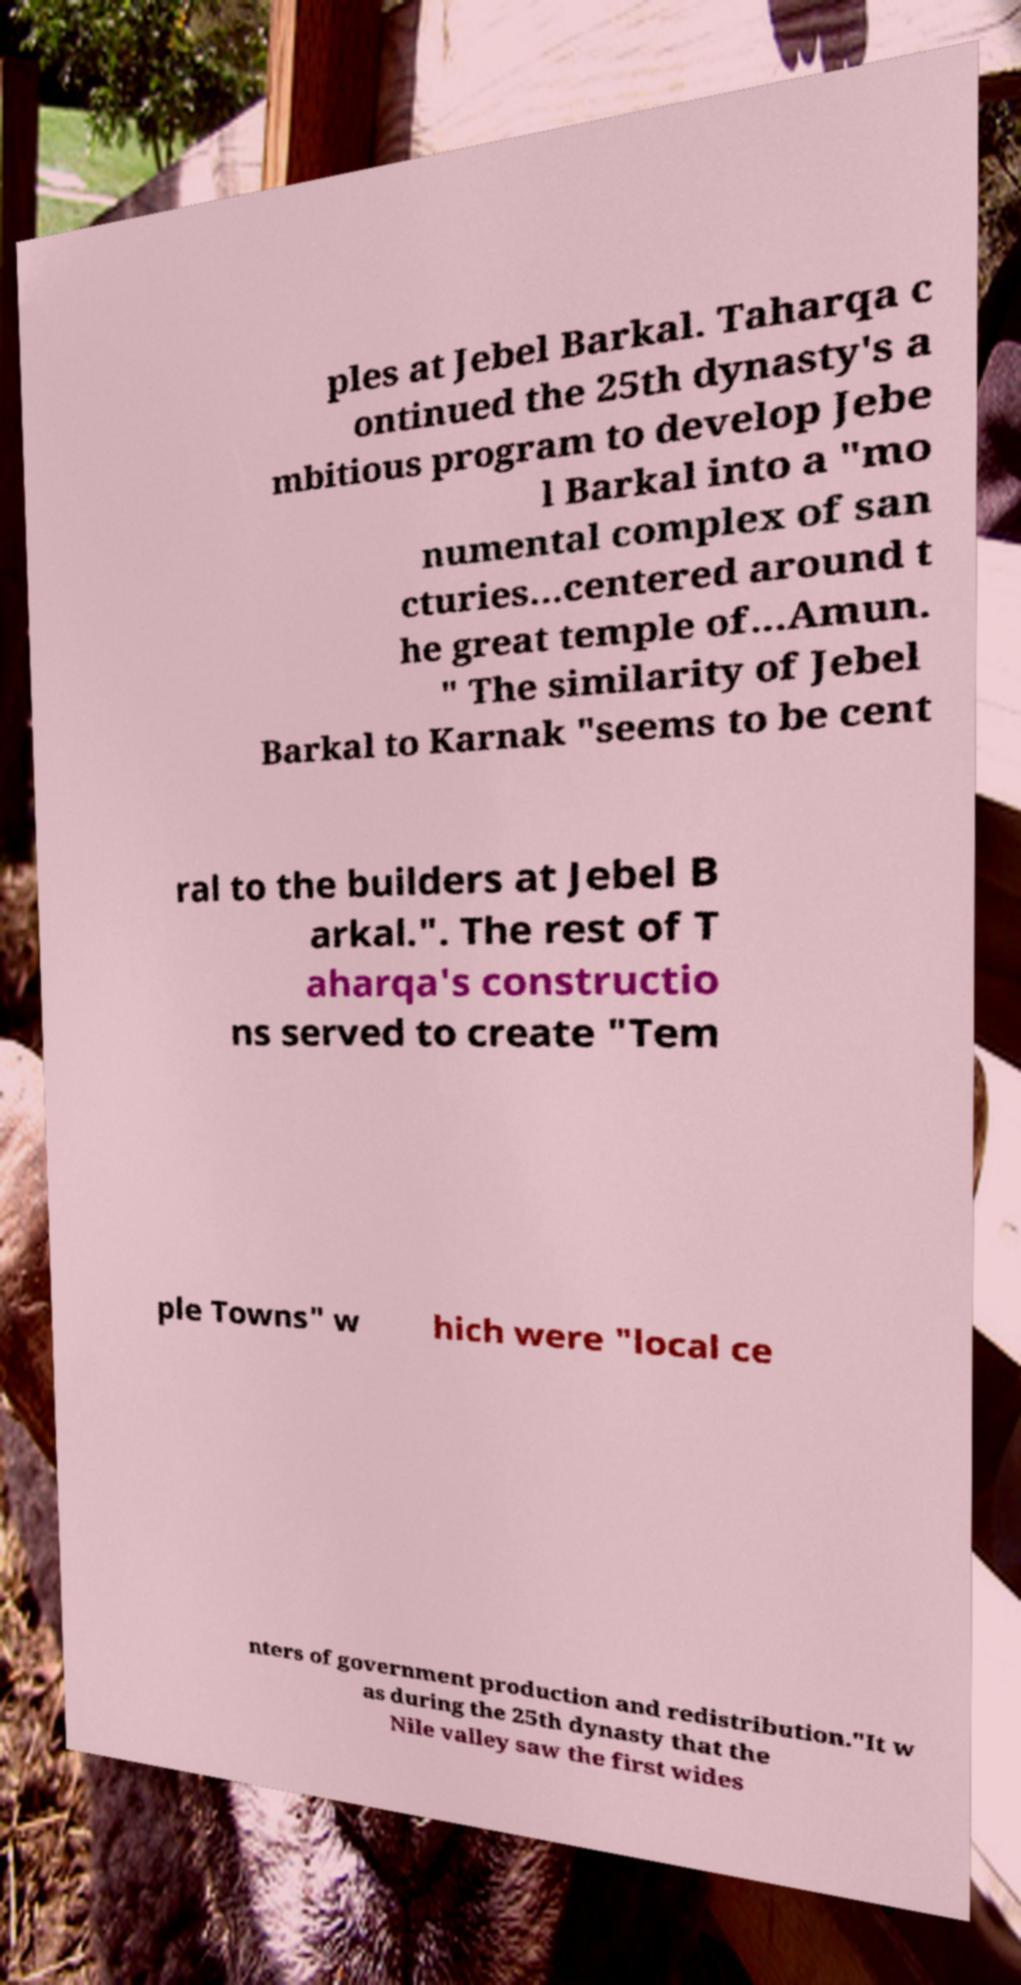I need the written content from this picture converted into text. Can you do that? ples at Jebel Barkal. Taharqa c ontinued the 25th dynasty's a mbitious program to develop Jebe l Barkal into a "mo numental complex of san cturies...centered around t he great temple of...Amun. " The similarity of Jebel Barkal to Karnak "seems to be cent ral to the builders at Jebel B arkal.". The rest of T aharqa's constructio ns served to create "Tem ple Towns" w hich were "local ce nters of government production and redistribution."It w as during the 25th dynasty that the Nile valley saw the first wides 